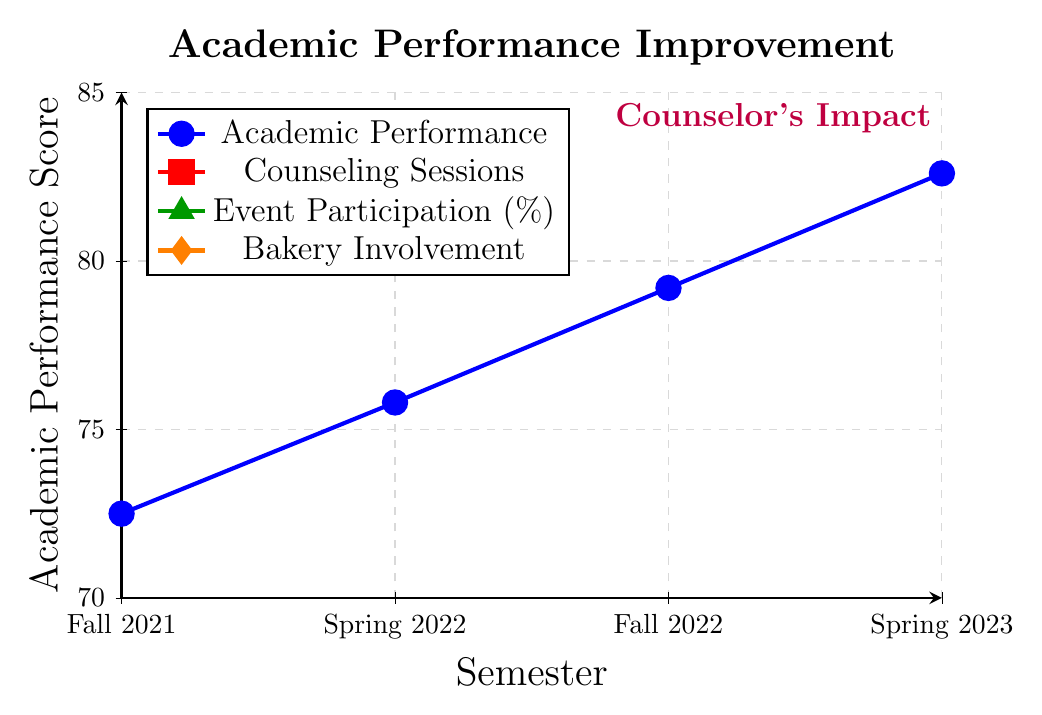what is the academic performance score in Spring 2023? We can look at the blue line representing Academic Performance and find the value for Spring 2023. The score is at 82.6.
Answer: 82.6 How many counseling sessions were attended by students in Fall 2022? We refer to the red line representing Counseling Sessions and find the value for Fall 2022. The number of sessions attended is 7.
Answer: 7 By how much did the event participation rate increase from Fall 2021 to Spring 2023? Looking at the green line representing Event Participation Rate, we see that it increased from 45% in Fall 2021 to 68% in Spring 2023. The increase is 68% - 45% = 23%.
Answer: 23% Which semester had the lowest bakery involvement score? By observing the orange diamond markers, we find the lowest bakery involvement score in Fall 2021, with a score of 2.1.
Answer: Fall 2021 In which semester was the difference between the number of counseling sessions and the bakery involvement score the largest? We need to calculate the difference in each semester:
Fall 2021: 3 - 2.1 = 0.9
Spring 2022: 5 - 2.7 = 2.3
Fall 2022: 7 - 3.4 = 3.6
Spring 2023: 8 - 4.2 = 3.8
The difference is largest in Spring 2023.
Answer: Spring 2023 How did the academic performance score change from Fall 2021 to Spring 2023? Analyzing the blue line, we observe that the score increased from 72.5 in Fall 2021 to 82.6 in Spring 2023. The change is 82.6 - 72.5 = 10.1 points.
Answer: 10.1 points What is the color representing event participation rate in the figure? Looking at the legend of the plot, the line representing Event Participation is colored green.
Answer: Green What was the average number of counseling sessions per semester? Adding the number of sessions for each semester and dividing by 4: (3 + 5 + 7 + 8) / 4 = 23 / 4 = 5.75.
Answer: 5.75 Is there a correlation between the number of counseling sessions and academic performance scores across the semesters? Observing the red and blue lines, we see that as the number of counseling sessions increased, the academic performance scores also increased. This suggests a positive correlation.
Answer: Yes Between which two consecutive semesters was the increase in bakery involvement score the greatest? Calculating the differences between consecutive semesters:
Fall 2021 to Spring 2022: 2.7 - 2.1 = 0.6
Spring 2022 to Fall 2022: 3.4 - 2.7 = 0.7
Fall 2022 to Spring 2023: 4.2 - 3.4 = 0.8
The greatest increase was between Fall 2022 and Spring 2023.
Answer: Fall 2022 and Spring 2023 